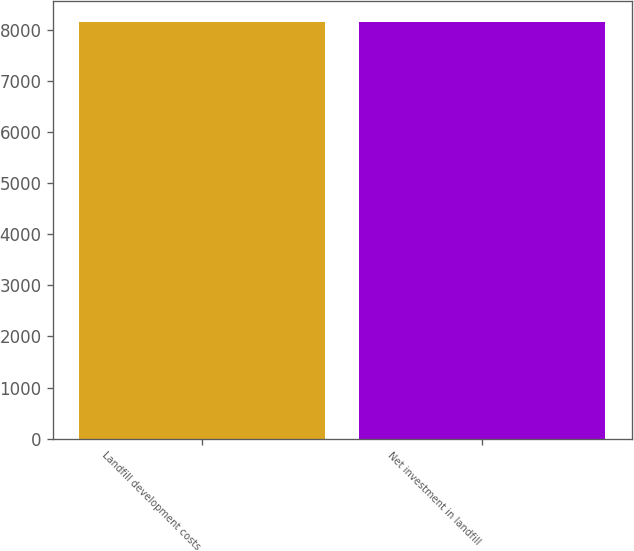Convert chart to OTSL. <chart><loc_0><loc_0><loc_500><loc_500><bar_chart><fcel>Landfill development costs<fcel>Net investment in landfill<nl><fcel>8153.3<fcel>8153.4<nl></chart> 